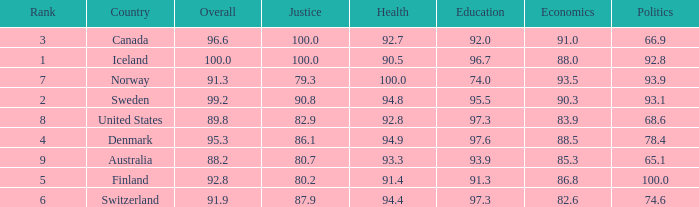Could you help me parse every detail presented in this table? {'header': ['Rank', 'Country', 'Overall', 'Justice', 'Health', 'Education', 'Economics', 'Politics'], 'rows': [['3', 'Canada', '96.6', '100.0', '92.7', '92.0', '91.0', '66.9'], ['1', 'Iceland', '100.0', '100.0', '90.5', '96.7', '88.0', '92.8'], ['7', 'Norway', '91.3', '79.3', '100.0', '74.0', '93.5', '93.9'], ['2', 'Sweden', '99.2', '90.8', '94.8', '95.5', '90.3', '93.1'], ['8', 'United States', '89.8', '82.9', '92.8', '97.3', '83.9', '68.6'], ['4', 'Denmark', '95.3', '86.1', '94.9', '97.6', '88.5', '78.4'], ['9', 'Australia', '88.2', '80.7', '93.3', '93.9', '85.3', '65.1'], ['5', 'Finland', '92.8', '80.2', '91.4', '91.3', '86.8', '100.0'], ['6', 'Switzerland', '91.9', '87.9', '94.4', '97.3', '82.6', '74.6']]} What's the health score with justice being 80.7 93.3. 